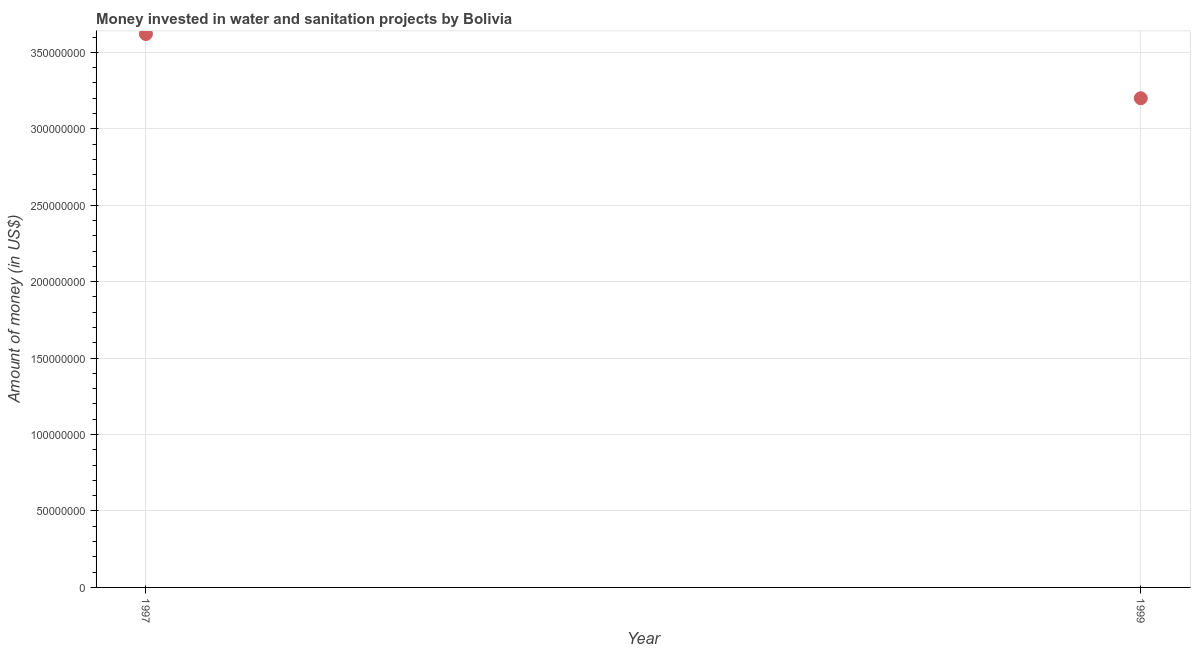What is the investment in 1999?
Keep it short and to the point. 3.20e+08. Across all years, what is the maximum investment?
Give a very brief answer. 3.62e+08. Across all years, what is the minimum investment?
Provide a short and direct response. 3.20e+08. In which year was the investment maximum?
Ensure brevity in your answer.  1997. In which year was the investment minimum?
Give a very brief answer. 1999. What is the sum of the investment?
Keep it short and to the point. 6.82e+08. What is the difference between the investment in 1997 and 1999?
Offer a terse response. 4.20e+07. What is the average investment per year?
Provide a succinct answer. 3.41e+08. What is the median investment?
Your answer should be compact. 3.41e+08. Do a majority of the years between 1999 and 1997 (inclusive) have investment greater than 250000000 US$?
Give a very brief answer. No. What is the ratio of the investment in 1997 to that in 1999?
Your answer should be compact. 1.13. Does the investment monotonically increase over the years?
Ensure brevity in your answer.  No. How many dotlines are there?
Your answer should be compact. 1. What is the difference between two consecutive major ticks on the Y-axis?
Provide a succinct answer. 5.00e+07. Does the graph contain any zero values?
Your answer should be very brief. No. Does the graph contain grids?
Your answer should be compact. Yes. What is the title of the graph?
Keep it short and to the point. Money invested in water and sanitation projects by Bolivia. What is the label or title of the Y-axis?
Ensure brevity in your answer.  Amount of money (in US$). What is the Amount of money (in US$) in 1997?
Your answer should be compact. 3.62e+08. What is the Amount of money (in US$) in 1999?
Keep it short and to the point. 3.20e+08. What is the difference between the Amount of money (in US$) in 1997 and 1999?
Keep it short and to the point. 4.20e+07. What is the ratio of the Amount of money (in US$) in 1997 to that in 1999?
Your answer should be very brief. 1.13. 